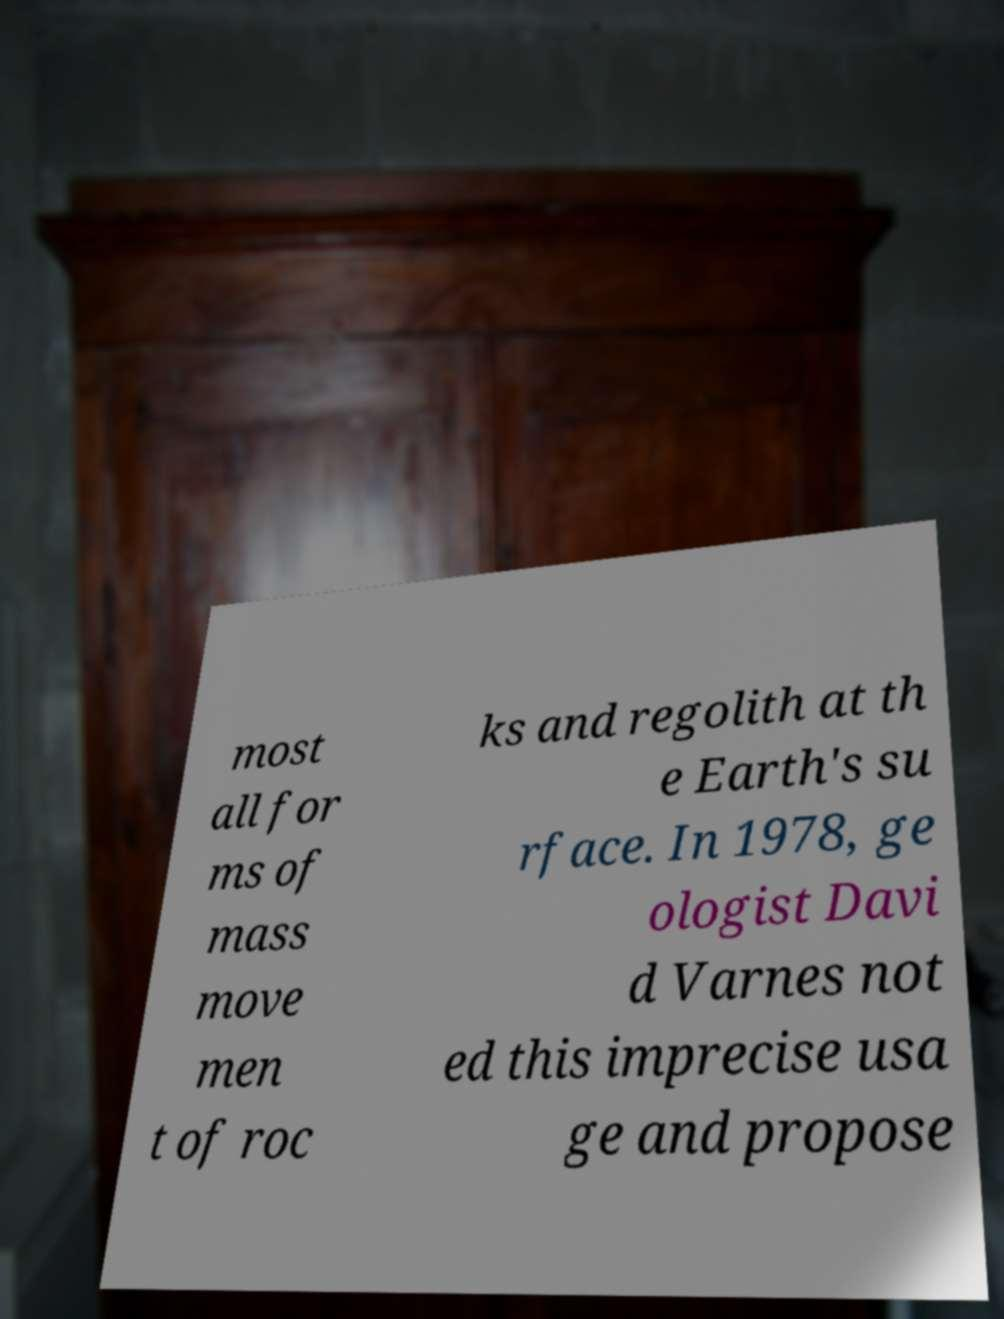Could you extract and type out the text from this image? most all for ms of mass move men t of roc ks and regolith at th e Earth's su rface. In 1978, ge ologist Davi d Varnes not ed this imprecise usa ge and propose 